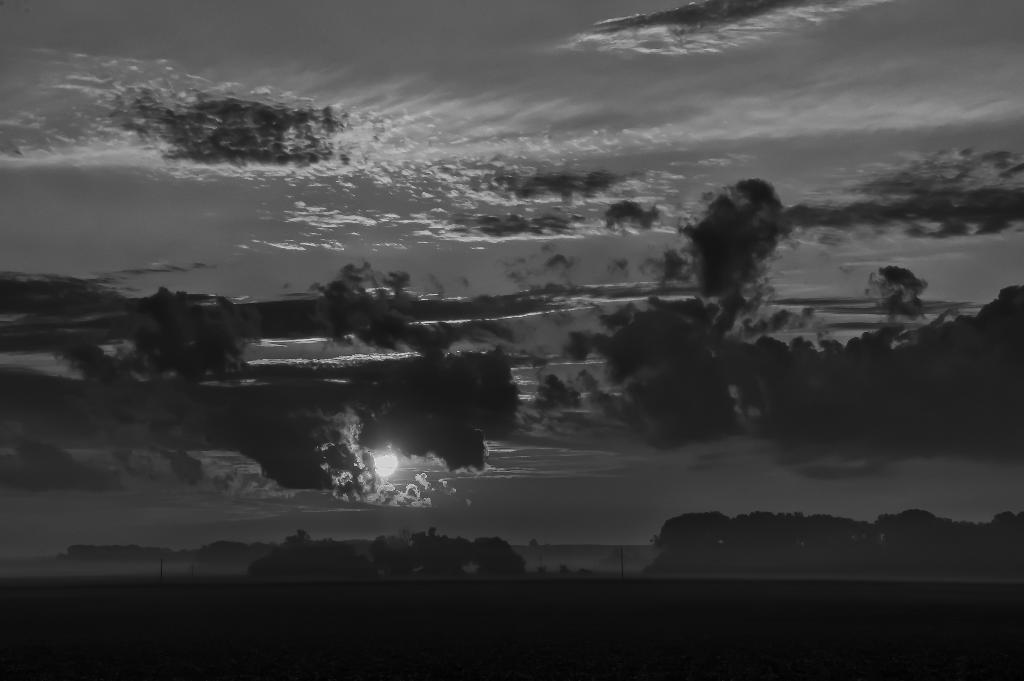What type of natural elements can be seen in the image? There are trees and mountains visible in the image. What man-made structures are present in the image? There are poles in the image. What celestial body is visible in the image? There is a moon visible in the image. What can be seen in the sky in the image? There are clouds in the sky in the image. What type of invention is being demonstrated in the image? There is no invention being demonstrated in the image. How many bikes are visible in the image? There are no bikes present in the image. 